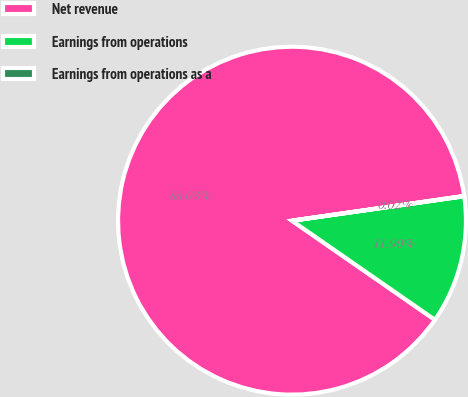<chart> <loc_0><loc_0><loc_500><loc_500><pie_chart><fcel>Net revenue<fcel>Earnings from operations<fcel>Earnings from operations as a<nl><fcel>88.08%<fcel>11.9%<fcel>0.02%<nl></chart> 